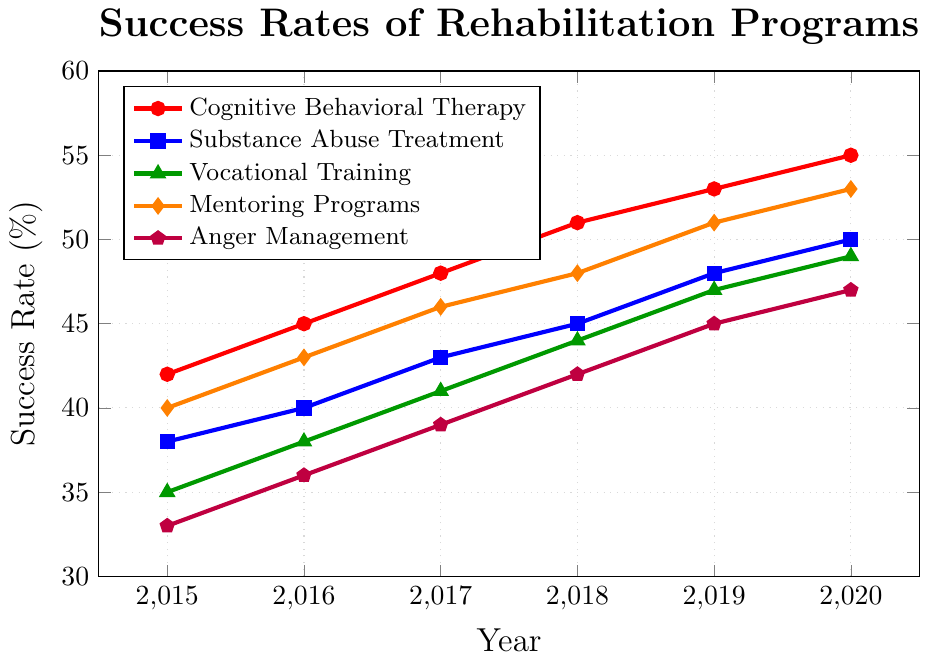What's the overall trend in the success rate of Cognitive Behavioral Therapy from 2015 to 2020? The success rate of Cognitive Behavioral Therapy increases every year. From 2015 to 2020, the success rate rises from 42% to 55%.
Answer: Increasing Which rehabilitation program showed the highest success rate in 2020? Cognitive Behavioral Therapy and Mentoring Programs both have the highest success rate in 2020, which is 55% and 53% respectively. As Cognitive Behavioral Therapy is slightly higher, it has the highest success rate.
Answer: Cognitive Behavioral Therapy What was the success rate of Vocational Training in 2017, and how does it compare to Substance Abuse Treatment the same year? In 2017, the success rate for Vocational Training was 41%, while for Substance Abuse Treatment, it was 43%. Vocational Training's success rate was 2 percentage points lower than Substance Abuse Treatment.
Answer: 41%, 2 percentage points lower Which program had the lowest success rate in 2018, and what was it? Anger Management had the lowest success rate in 2018, with a success rate of 42%.
Answer: Anger Management, 42% What is the average success rate of Mentoring Programs over the years? The success rates for Mentoring Programs from 2015 to 2020 are 40%, 43%, 46%, 48%, 51%, and 53%. Adding these, we have: 40 + 43 + 46 + 48 + 51 + 53 = 281. Dividing by 6, the average is 281/6 ≈ 46.83%.
Answer: 46.83% Between which two consecutive years did Substance Abuse Treatment see the highest increase in success rate? The success rates for Substance Abuse Treatment are 38% (2015), 40% (2016), 43% (2017), 45% (2018), 48% (2019), and 50% (2020). The increases are 2%, 3%, 2%, 3%, and 2% respectively. The highest increase of 3% is observed from 2016 to 2017, and again from 2018 to 2019.
Answer: 2016 to 2017 and 2018 to 2019 What was the success rate trend for Anger Management from 2015 to 2020? The success rate of Anger Management shows a steady increase each year. In 2015, it was 33%, increasing to 47% by 2020.
Answer: Increasing Compare the success rates of Cognitive Behavioral Therapy and Anger Management in 2019. In 2019, the success rate for Cognitive Behavioral Therapy was 53%, while for Anger Management, it was 45%. Cognitive Behavioral Therapy had an 8 percentage points higher success rate than Anger Management.
Answer: Cognitive Behavioral Therapy had a higher success rate by 8 percentage points How much did the success rate of Cognitive Behavioral Therapy improve between 2015 and 2020? The success rate for Cognitive Behavioral Therapy increased from 42% in 2015 to 55% in 2020. The improvement is 55% - 42% = 13%.
Answer: 13% What visual attribute identifies the Substance Abuse Treatment program in the plot? In the plot, the Substance Abuse Treatment program is identified by the blue color and square markers.
Answer: Blue color and square markers 